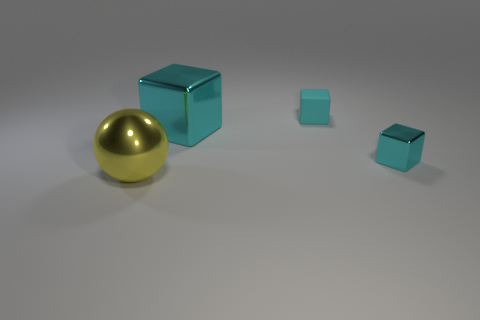What number of things are either big cyan things or metallic objects?
Give a very brief answer. 3. What is the size of the object that is both on the left side of the small cyan matte thing and on the right side of the metal sphere?
Provide a succinct answer. Large. What number of red cubes are there?
Make the answer very short. 0. What number of cylinders are either cyan matte things or large yellow metallic objects?
Your answer should be compact. 0. There is a tiny cyan object in front of the tiny cyan thing on the left side of the small cyan metallic thing; how many large yellow spheres are in front of it?
Give a very brief answer. 1. What is the color of the block that is the same size as the yellow ball?
Ensure brevity in your answer.  Cyan. What number of other things are there of the same color as the tiny metal object?
Your response must be concise. 2. Are there more large things to the right of the small cyan shiny cube than big cyan shiny objects?
Make the answer very short. No. Do the yellow sphere and the big cyan object have the same material?
Your answer should be very brief. Yes. How many objects are big balls that are in front of the small cyan matte thing or large cyan metallic objects?
Provide a short and direct response. 2. 